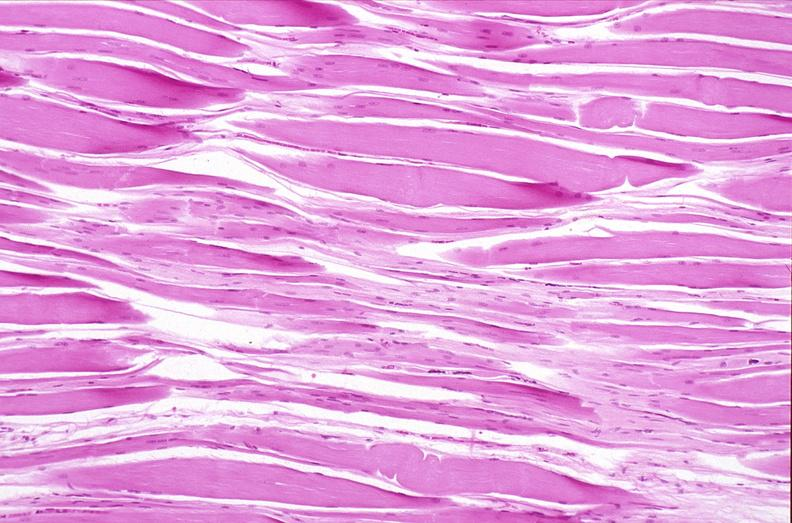does atheromatous embolus show skeletal muscle, atrophy due to immobilization cast?
Answer the question using a single word or phrase. No 